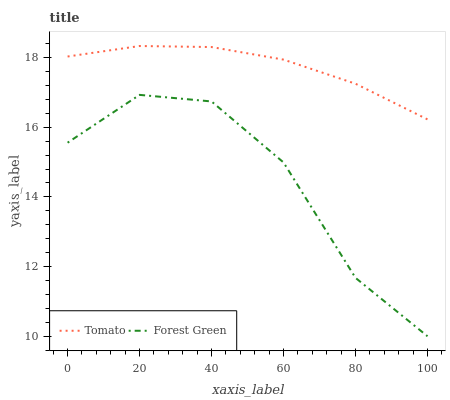Does Forest Green have the minimum area under the curve?
Answer yes or no. Yes. Does Tomato have the maximum area under the curve?
Answer yes or no. Yes. Does Forest Green have the maximum area under the curve?
Answer yes or no. No. Is Tomato the smoothest?
Answer yes or no. Yes. Is Forest Green the roughest?
Answer yes or no. Yes. Is Forest Green the smoothest?
Answer yes or no. No. Does Forest Green have the lowest value?
Answer yes or no. Yes. Does Tomato have the highest value?
Answer yes or no. Yes. Does Forest Green have the highest value?
Answer yes or no. No. Is Forest Green less than Tomato?
Answer yes or no. Yes. Is Tomato greater than Forest Green?
Answer yes or no. Yes. Does Forest Green intersect Tomato?
Answer yes or no. No. 